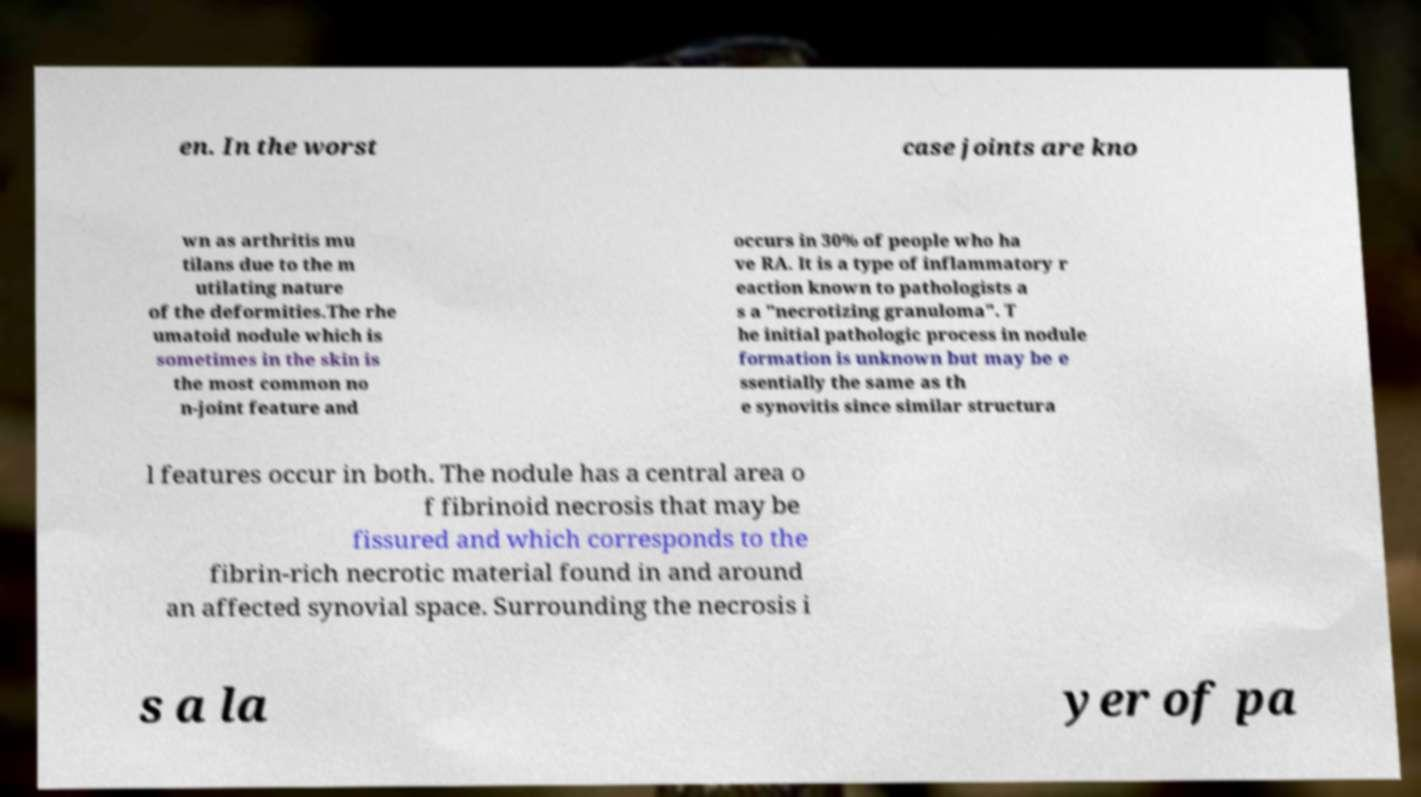Can you accurately transcribe the text from the provided image for me? en. In the worst case joints are kno wn as arthritis mu tilans due to the m utilating nature of the deformities.The rhe umatoid nodule which is sometimes in the skin is the most common no n-joint feature and occurs in 30% of people who ha ve RA. It is a type of inflammatory r eaction known to pathologists a s a "necrotizing granuloma". T he initial pathologic process in nodule formation is unknown but may be e ssentially the same as th e synovitis since similar structura l features occur in both. The nodule has a central area o f fibrinoid necrosis that may be fissured and which corresponds to the fibrin-rich necrotic material found in and around an affected synovial space. Surrounding the necrosis i s a la yer of pa 